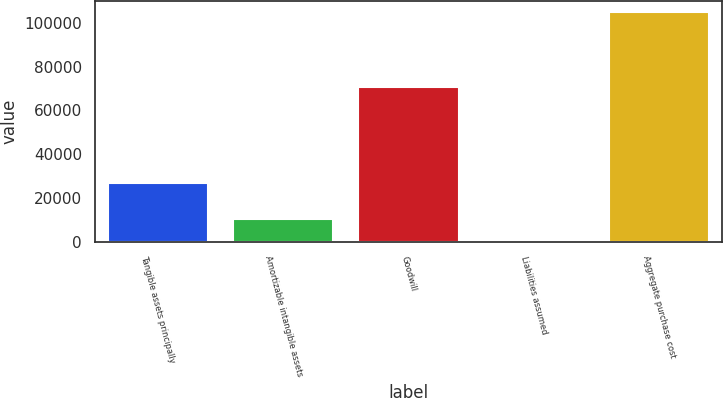Convert chart to OTSL. <chart><loc_0><loc_0><loc_500><loc_500><bar_chart><fcel>Tangible assets principally<fcel>Amortizable intangible assets<fcel>Goodwill<fcel>Liabilities assumed<fcel>Aggregate purchase cost<nl><fcel>26678<fcel>10605.1<fcel>70700<fcel>140<fcel>104791<nl></chart> 